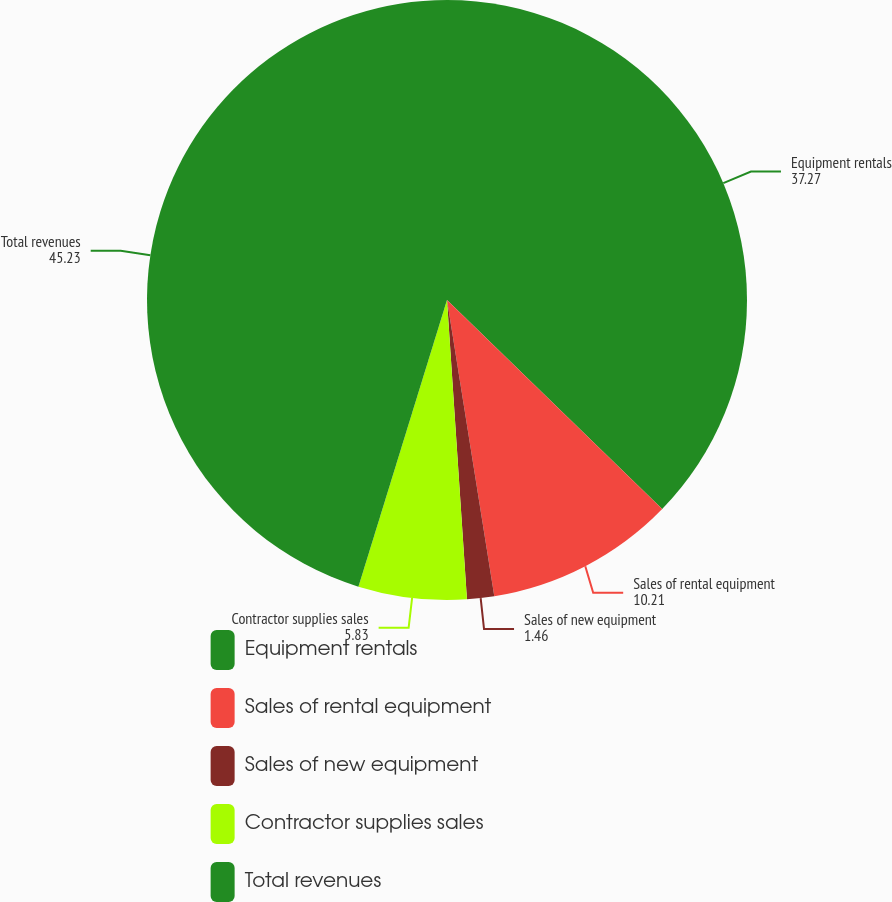Convert chart. <chart><loc_0><loc_0><loc_500><loc_500><pie_chart><fcel>Equipment rentals<fcel>Sales of rental equipment<fcel>Sales of new equipment<fcel>Contractor supplies sales<fcel>Total revenues<nl><fcel>37.27%<fcel>10.21%<fcel>1.46%<fcel>5.83%<fcel>45.23%<nl></chart> 